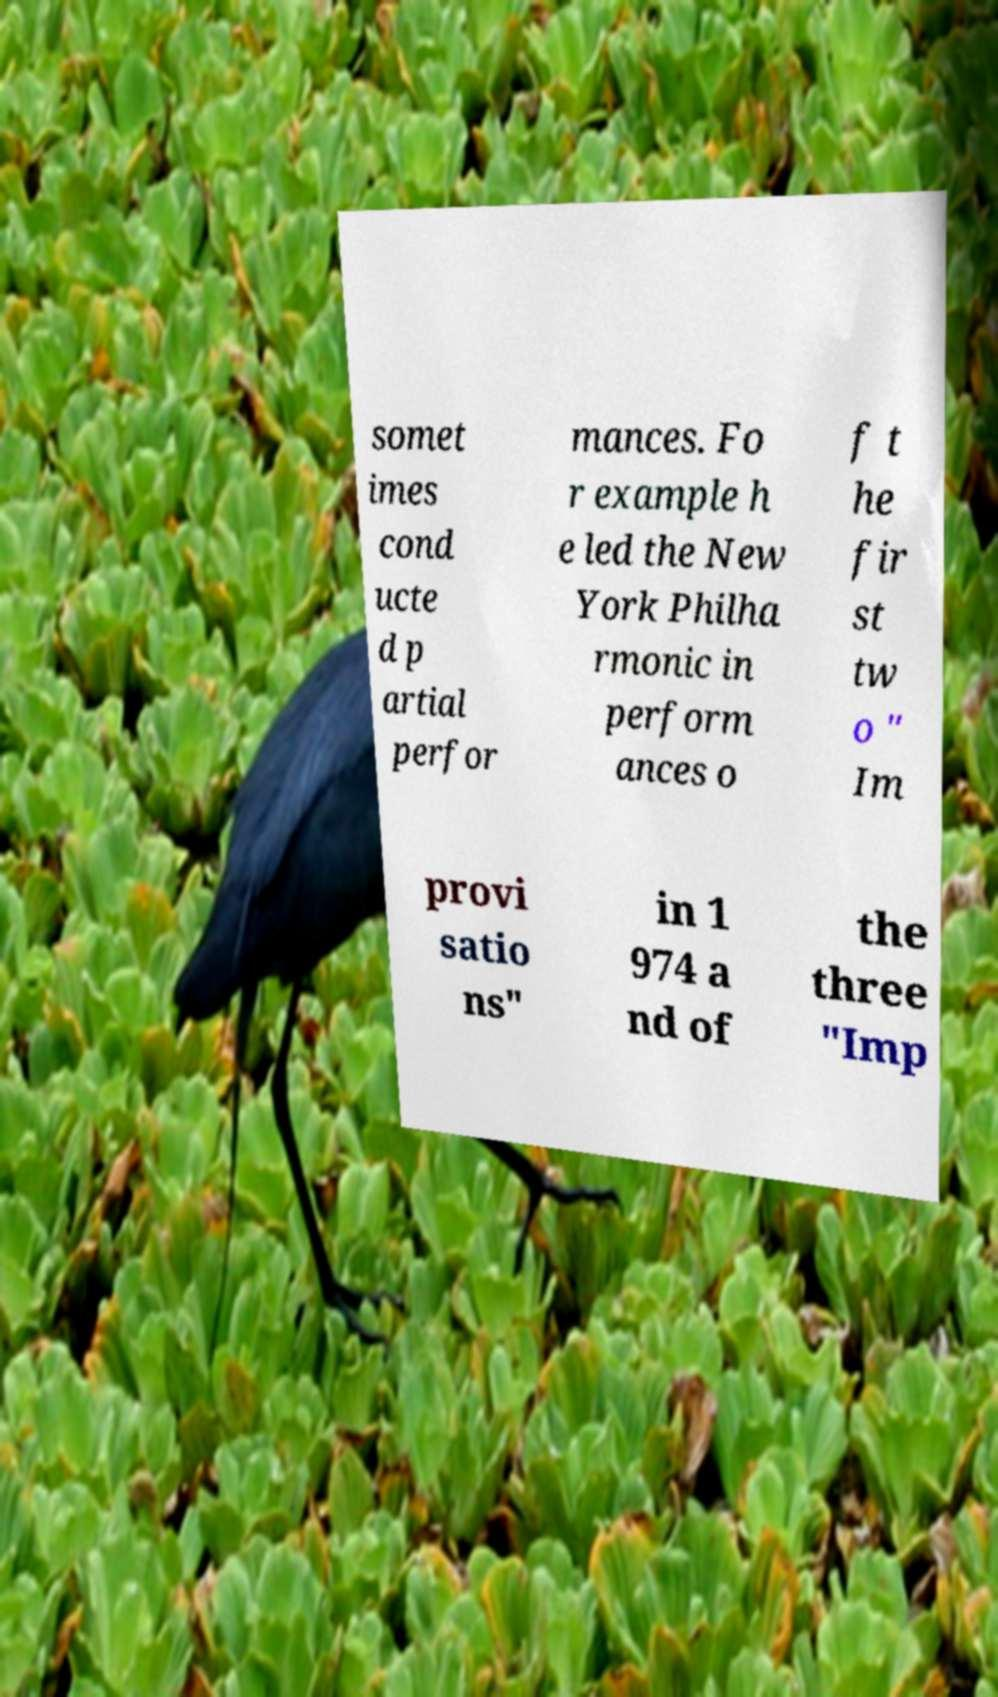Could you extract and type out the text from this image? somet imes cond ucte d p artial perfor mances. Fo r example h e led the New York Philha rmonic in perform ances o f t he fir st tw o " Im provi satio ns" in 1 974 a nd of the three "Imp 